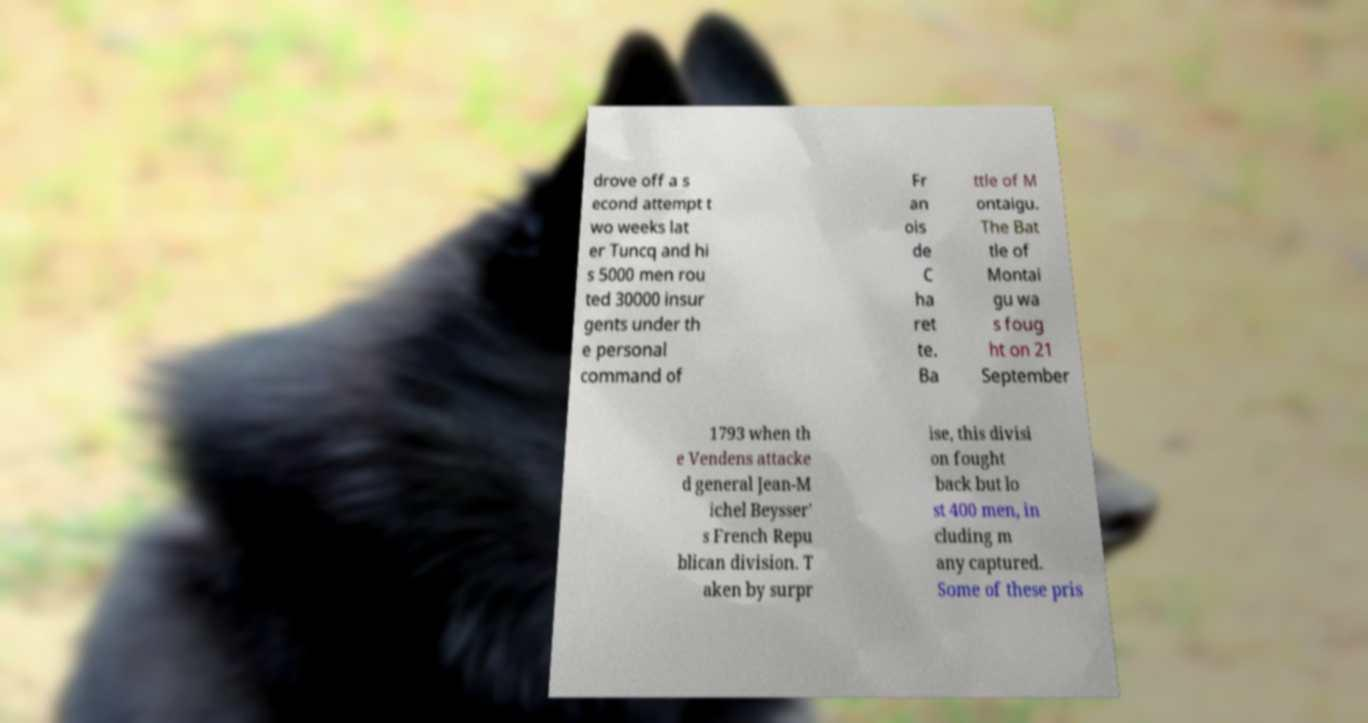There's text embedded in this image that I need extracted. Can you transcribe it verbatim? drove off a s econd attempt t wo weeks lat er Tuncq and hi s 5000 men rou ted 30000 insur gents under th e personal command of Fr an ois de C ha ret te. Ba ttle of M ontaigu. The Bat tle of Montai gu wa s foug ht on 21 September 1793 when th e Vendens attacke d general Jean-M ichel Beysser' s French Repu blican division. T aken by surpr ise, this divisi on fought back but lo st 400 men, in cluding m any captured. Some of these pris 